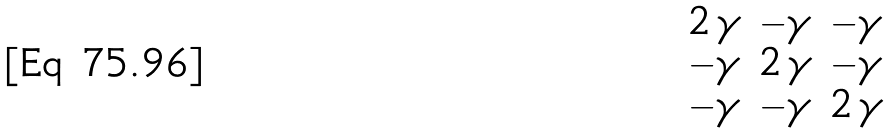Convert formula to latex. <formula><loc_0><loc_0><loc_500><loc_500>\begin{matrix} 2 \, \gamma & - \gamma & - \gamma \\ - \gamma & 2 \, \gamma & - \gamma \\ - \gamma & - \gamma & 2 \, \gamma \end{matrix}</formula> 